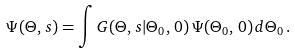Convert formula to latex. <formula><loc_0><loc_0><loc_500><loc_500>\Psi ( \Theta , \, s ) = \int G ( \Theta , \, s | \Theta _ { 0 } , \, 0 ) \, \Psi ( \Theta _ { 0 } , \, 0 ) \, d \Theta _ { 0 } \, .</formula> 